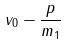Convert formula to latex. <formula><loc_0><loc_0><loc_500><loc_500>v _ { 0 } - \frac { p } { m _ { 1 } }</formula> 